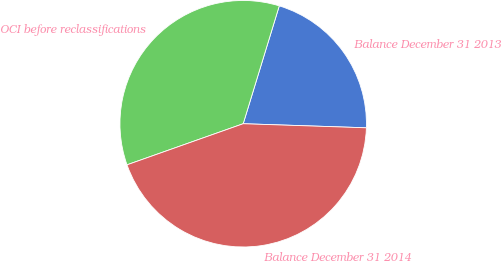<chart> <loc_0><loc_0><loc_500><loc_500><pie_chart><fcel>Balance December 31 2013<fcel>OCI before reclassifications<fcel>Balance December 31 2014<nl><fcel>20.8%<fcel>35.14%<fcel>44.06%<nl></chart> 